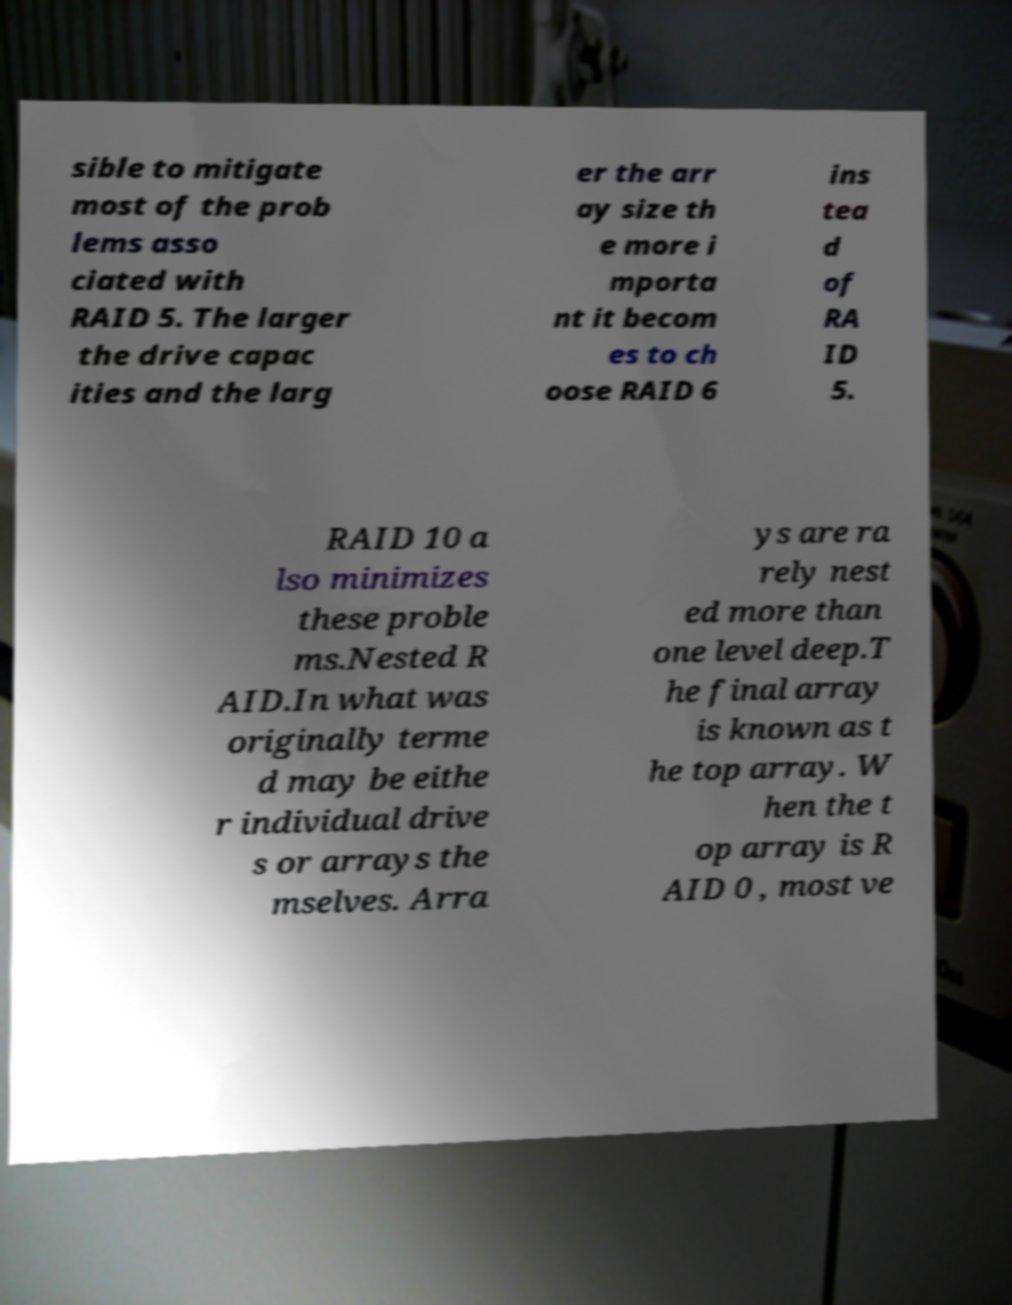I need the written content from this picture converted into text. Can you do that? sible to mitigate most of the prob lems asso ciated with RAID 5. The larger the drive capac ities and the larg er the arr ay size th e more i mporta nt it becom es to ch oose RAID 6 ins tea d of RA ID 5. RAID 10 a lso minimizes these proble ms.Nested R AID.In what was originally terme d may be eithe r individual drive s or arrays the mselves. Arra ys are ra rely nest ed more than one level deep.T he final array is known as t he top array. W hen the t op array is R AID 0 , most ve 